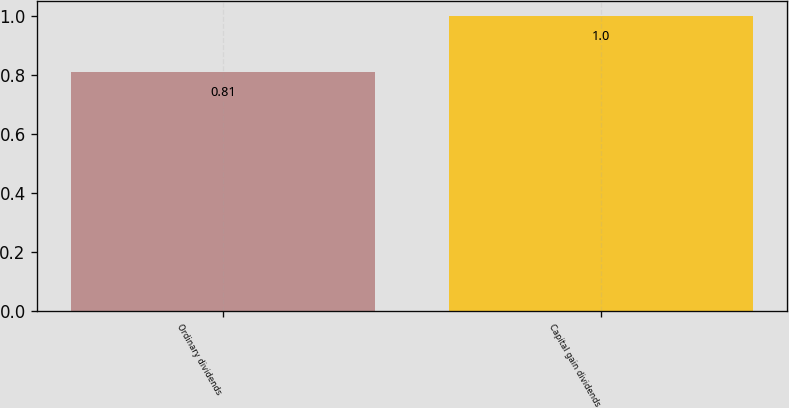<chart> <loc_0><loc_0><loc_500><loc_500><bar_chart><fcel>Ordinary dividends<fcel>Capital gain dividends<nl><fcel>0.81<fcel>1<nl></chart> 